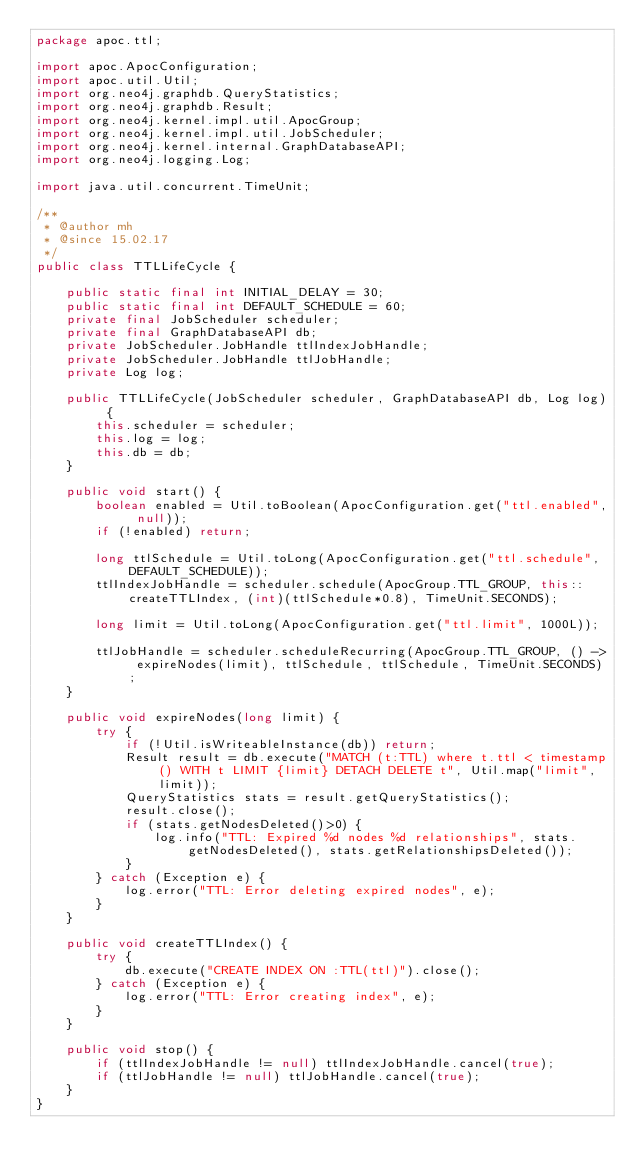<code> <loc_0><loc_0><loc_500><loc_500><_Java_>package apoc.ttl;

import apoc.ApocConfiguration;
import apoc.util.Util;
import org.neo4j.graphdb.QueryStatistics;
import org.neo4j.graphdb.Result;
import org.neo4j.kernel.impl.util.ApocGroup;
import org.neo4j.kernel.impl.util.JobScheduler;
import org.neo4j.kernel.internal.GraphDatabaseAPI;
import org.neo4j.logging.Log;

import java.util.concurrent.TimeUnit;

/**
 * @author mh
 * @since 15.02.17
 */
public class TTLLifeCycle {

    public static final int INITIAL_DELAY = 30;
    public static final int DEFAULT_SCHEDULE = 60;
    private final JobScheduler scheduler;
    private final GraphDatabaseAPI db;
    private JobScheduler.JobHandle ttlIndexJobHandle;
    private JobScheduler.JobHandle ttlJobHandle;
    private Log log;

    public TTLLifeCycle(JobScheduler scheduler, GraphDatabaseAPI db, Log log) {
        this.scheduler = scheduler;
        this.log = log;
        this.db = db;
    }

    public void start() {
        boolean enabled = Util.toBoolean(ApocConfiguration.get("ttl.enabled", null));
        if (!enabled) return;

        long ttlSchedule = Util.toLong(ApocConfiguration.get("ttl.schedule", DEFAULT_SCHEDULE));
        ttlIndexJobHandle = scheduler.schedule(ApocGroup.TTL_GROUP, this::createTTLIndex, (int)(ttlSchedule*0.8), TimeUnit.SECONDS);

        long limit = Util.toLong(ApocConfiguration.get("ttl.limit", 1000L));

        ttlJobHandle = scheduler.scheduleRecurring(ApocGroup.TTL_GROUP, () -> expireNodes(limit), ttlSchedule, ttlSchedule, TimeUnit.SECONDS);
    }

    public void expireNodes(long limit) {
        try {
            if (!Util.isWriteableInstance(db)) return;
            Result result = db.execute("MATCH (t:TTL) where t.ttl < timestamp() WITH t LIMIT {limit} DETACH DELETE t", Util.map("limit", limit));
            QueryStatistics stats = result.getQueryStatistics();
            result.close();
            if (stats.getNodesDeleted()>0) {
                log.info("TTL: Expired %d nodes %d relationships", stats.getNodesDeleted(), stats.getRelationshipsDeleted());
            }
        } catch (Exception e) {
            log.error("TTL: Error deleting expired nodes", e);
        }
    }

    public void createTTLIndex() {
        try {
            db.execute("CREATE INDEX ON :TTL(ttl)").close();
        } catch (Exception e) {
            log.error("TTL: Error creating index", e);
        }
    }

    public void stop() {
        if (ttlIndexJobHandle != null) ttlIndexJobHandle.cancel(true);
        if (ttlJobHandle != null) ttlJobHandle.cancel(true);
    }
}
</code> 